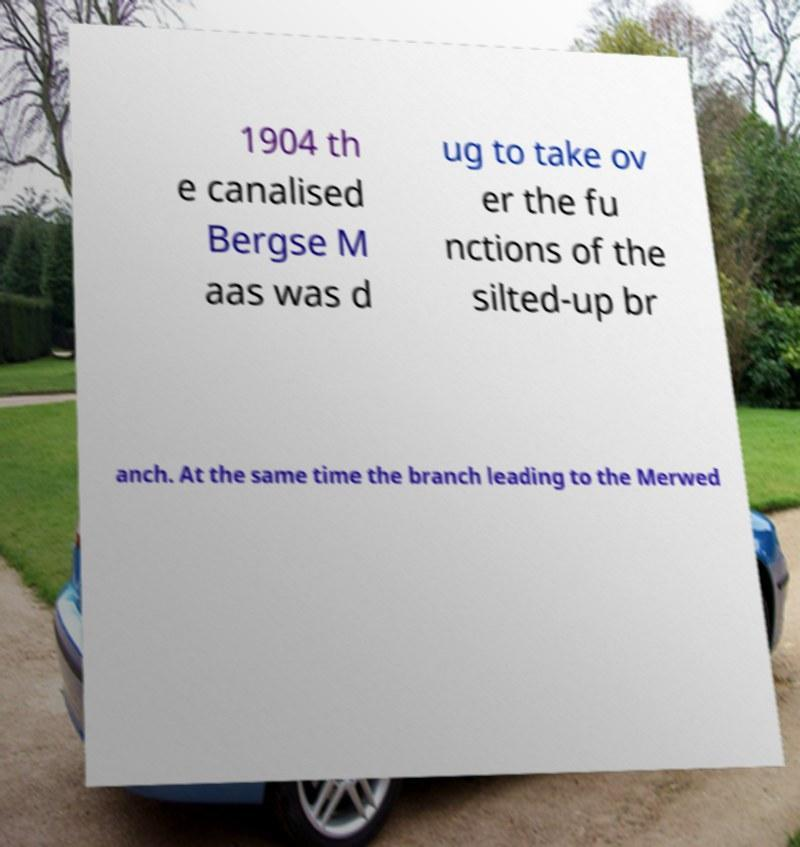There's text embedded in this image that I need extracted. Can you transcribe it verbatim? 1904 th e canalised Bergse M aas was d ug to take ov er the fu nctions of the silted-up br anch. At the same time the branch leading to the Merwed 